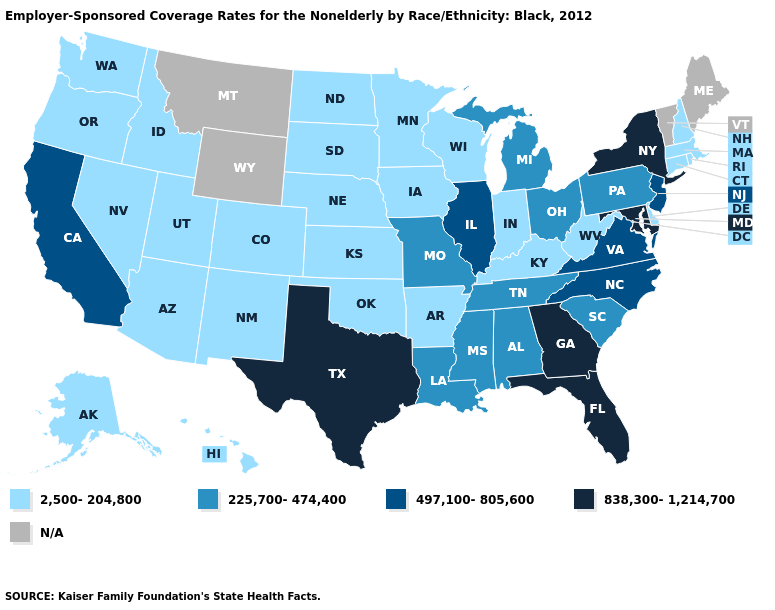Does Maryland have the highest value in the USA?
Keep it brief. Yes. What is the highest value in states that border Texas?
Give a very brief answer. 225,700-474,400. Is the legend a continuous bar?
Concise answer only. No. What is the value of Tennessee?
Write a very short answer. 225,700-474,400. Name the states that have a value in the range 225,700-474,400?
Concise answer only. Alabama, Louisiana, Michigan, Mississippi, Missouri, Ohio, Pennsylvania, South Carolina, Tennessee. Name the states that have a value in the range 2,500-204,800?
Write a very short answer. Alaska, Arizona, Arkansas, Colorado, Connecticut, Delaware, Hawaii, Idaho, Indiana, Iowa, Kansas, Kentucky, Massachusetts, Minnesota, Nebraska, Nevada, New Hampshire, New Mexico, North Dakota, Oklahoma, Oregon, Rhode Island, South Dakota, Utah, Washington, West Virginia, Wisconsin. What is the value of Pennsylvania?
Short answer required. 225,700-474,400. Name the states that have a value in the range 838,300-1,214,700?
Short answer required. Florida, Georgia, Maryland, New York, Texas. What is the highest value in the USA?
Keep it brief. 838,300-1,214,700. Among the states that border Maryland , which have the highest value?
Keep it brief. Virginia. How many symbols are there in the legend?
Keep it brief. 5. What is the value of Rhode Island?
Concise answer only. 2,500-204,800. What is the lowest value in the USA?
Be succinct. 2,500-204,800. Does Oregon have the highest value in the West?
Give a very brief answer. No. What is the value of West Virginia?
Keep it brief. 2,500-204,800. 